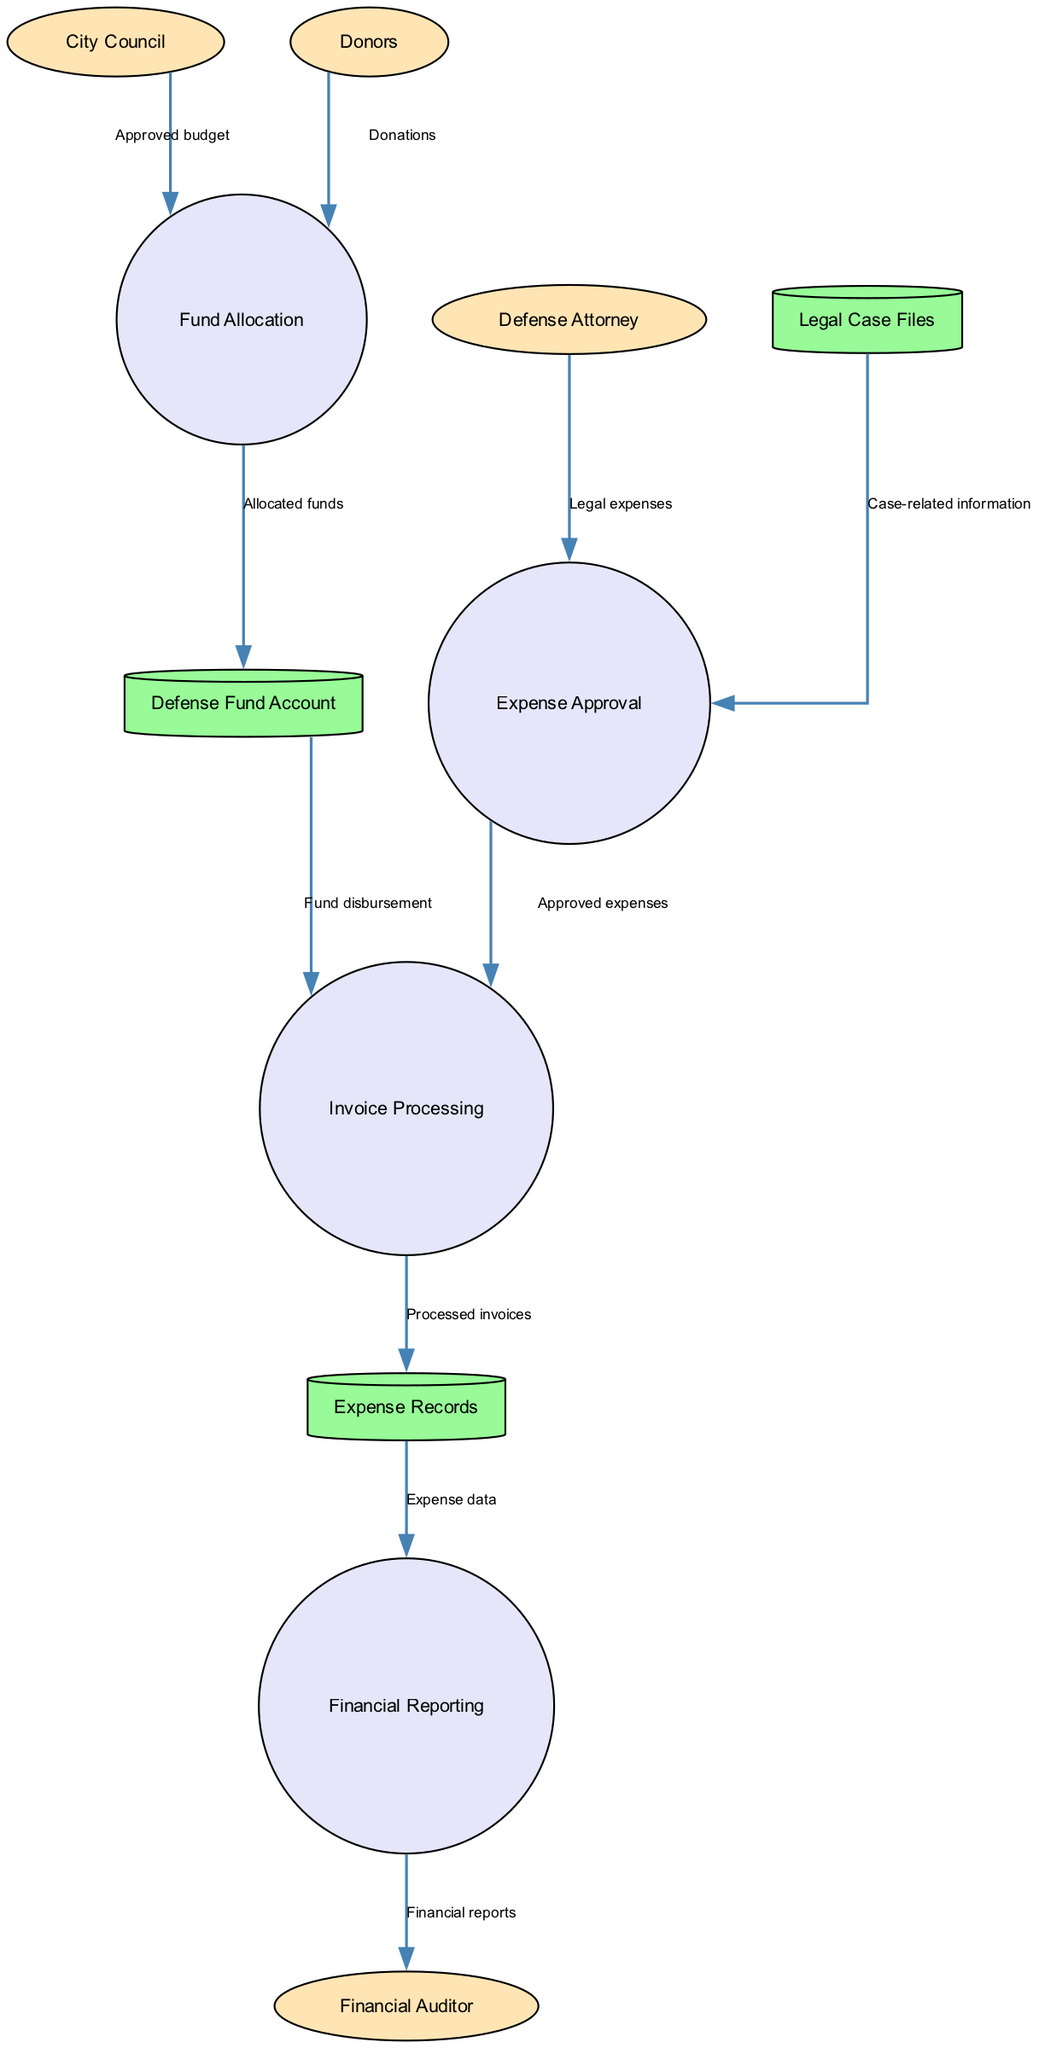What are the external entities represented in the diagram? The external entities are specifically labeled in the diagram. They include the City Council, Defense Attorney, Financial Auditor, and Donors.
Answer: City Council, Defense Attorney, Financial Auditor, Donors How many processes are outlined in the diagram? Counting the processes listed in the diagram, there are four distinct processes: Fund Allocation, Expense Approval, Invoice Processing, and Financial Reporting.
Answer: Four Which process receives the approved budget? The data flow labeled "Approved budget" is directed from the City Council to the process "Fund Allocation", indicating that Fund Allocation receives the approved budget.
Answer: Fund Allocation What is the source of the donations for the defense fund? The diagram shows that the donations are flowing from external entities labeled as Donors to the process of Fund Allocation, making Donors the source of the donations.
Answer: Donors What data store receives processed invoices? The Invoice Processing process leads to a data store labeled "Expense Records", meaning that processed invoices are stored in Expense Records.
Answer: Expense Records Which process is directly linked to case-related information? The process labeled "Expense Approval" receives data labeled "Case-related information" from the data store "Legal Case Files", indicating its direct link to case-related information.
Answer: Expense Approval What do the financial reports flow to? The data flow indicates that the "Financial Reporting" process sends its output, labeled as "Financial reports", to the "Financial Auditor", showing where the reports go.
Answer: Financial Auditor How many data stores are noted in the diagram? Counting the data stores within the diagram, there are three specified data stores: Defense Fund Account, Expense Records, and Legal Case Files, hence the total is three.
Answer: Three Which flow indicates fund disbursement? The flow labeled "Fund disbursement" is represented as directed from the "Defense Fund Account" to the "Invoice Processing" process, indicating this flow relates to fund disbursement.
Answer: Fund disbursement 